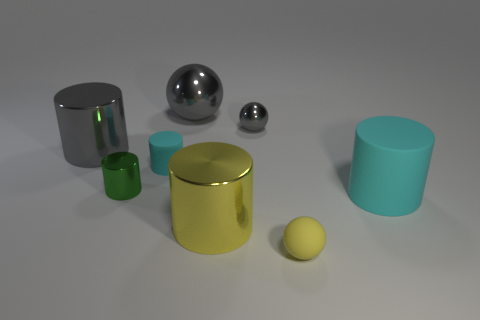What number of matte things have the same size as the yellow metallic object?
Your response must be concise. 1. Are there an equal number of big things on the right side of the large rubber thing and big things that are on the left side of the small yellow ball?
Your response must be concise. No. Is the large cyan object made of the same material as the tiny gray sphere?
Your response must be concise. No. Are there any metallic things that are in front of the small yellow ball that is right of the small gray shiny thing?
Keep it short and to the point. No. Are there any big cyan rubber objects that have the same shape as the big yellow thing?
Provide a succinct answer. Yes. Is the rubber ball the same color as the big matte cylinder?
Keep it short and to the point. No. What is the large gray thing that is on the right side of the cyan matte cylinder behind the green shiny cylinder made of?
Offer a very short reply. Metal. What size is the yellow ball?
Ensure brevity in your answer.  Small. What is the size of the yellow thing that is made of the same material as the big gray sphere?
Give a very brief answer. Large. Do the thing to the left of the green metallic cylinder and the big rubber object have the same size?
Your answer should be compact. Yes. 